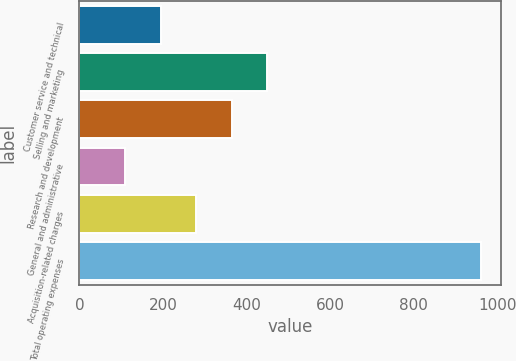Convert chart to OTSL. <chart><loc_0><loc_0><loc_500><loc_500><bar_chart><fcel>Customer service and technical<fcel>Selling and marketing<fcel>Research and development<fcel>General and administrative<fcel>Acquisition-related charges<fcel>Total operating expenses<nl><fcel>194.19<fcel>449.46<fcel>364.37<fcel>109.1<fcel>279.28<fcel>960<nl></chart> 